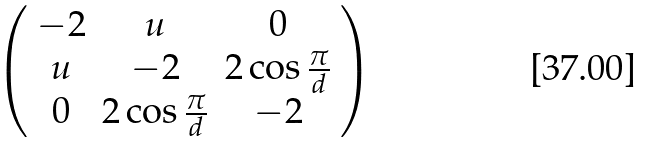<formula> <loc_0><loc_0><loc_500><loc_500>\left ( \begin{array} { c c c } - 2 & u & 0 \\ u & - 2 & 2 \cos { \frac { \pi } { d } } \\ 0 & 2 \cos { \frac { \pi } { d } } & - 2 \end{array} \right )</formula> 